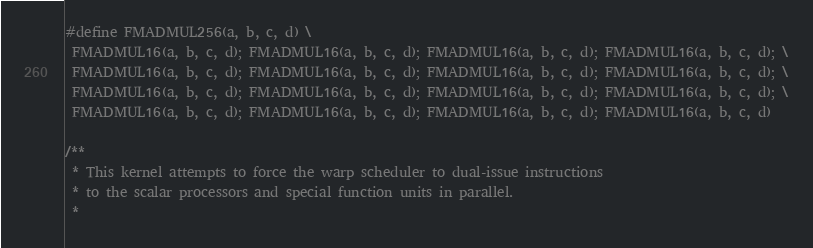<code> <loc_0><loc_0><loc_500><loc_500><_Cuda_>#define FMADMUL256(a, b, c, d) \
 FMADMUL16(a, b, c, d); FMADMUL16(a, b, c, d); FMADMUL16(a, b, c, d); FMADMUL16(a, b, c, d); \
 FMADMUL16(a, b, c, d); FMADMUL16(a, b, c, d); FMADMUL16(a, b, c, d); FMADMUL16(a, b, c, d); \
 FMADMUL16(a, b, c, d); FMADMUL16(a, b, c, d); FMADMUL16(a, b, c, d); FMADMUL16(a, b, c, d); \
 FMADMUL16(a, b, c, d); FMADMUL16(a, b, c, d); FMADMUL16(a, b, c, d); FMADMUL16(a, b, c, d)

/**
 * This kernel attempts to force the warp scheduler to dual-issue instructions
 * to the scalar processors and special function units in parallel.
 *</code> 